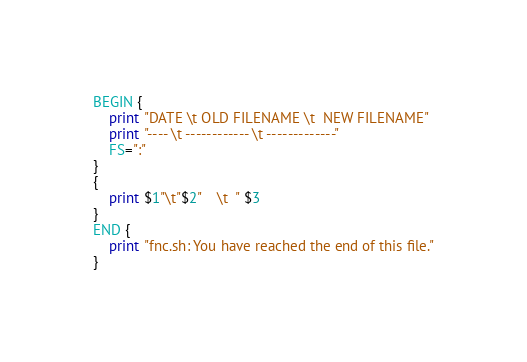<code> <loc_0><loc_0><loc_500><loc_500><_Awk_>BEGIN {
	print "DATE \t OLD FILENAME \t  NEW FILENAME"
	print "---- \t ------------ \t -------------"
	FS=":"
}
{
	print $1"\t"$2"    \t  " $3
}
END {
	print "fnc.sh: You have reached the end of this file."
}
</code> 